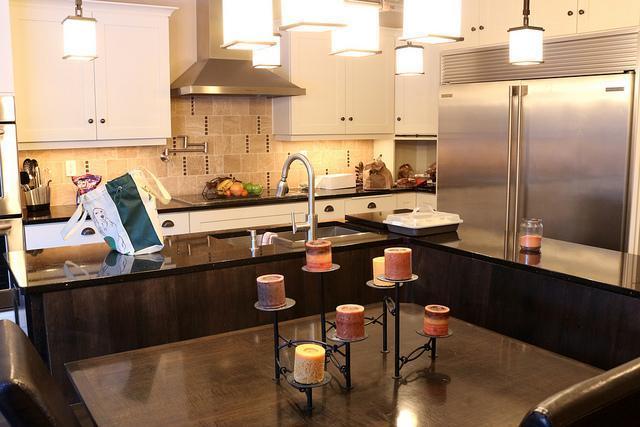How many chairs are in the picture?
Give a very brief answer. 2. 